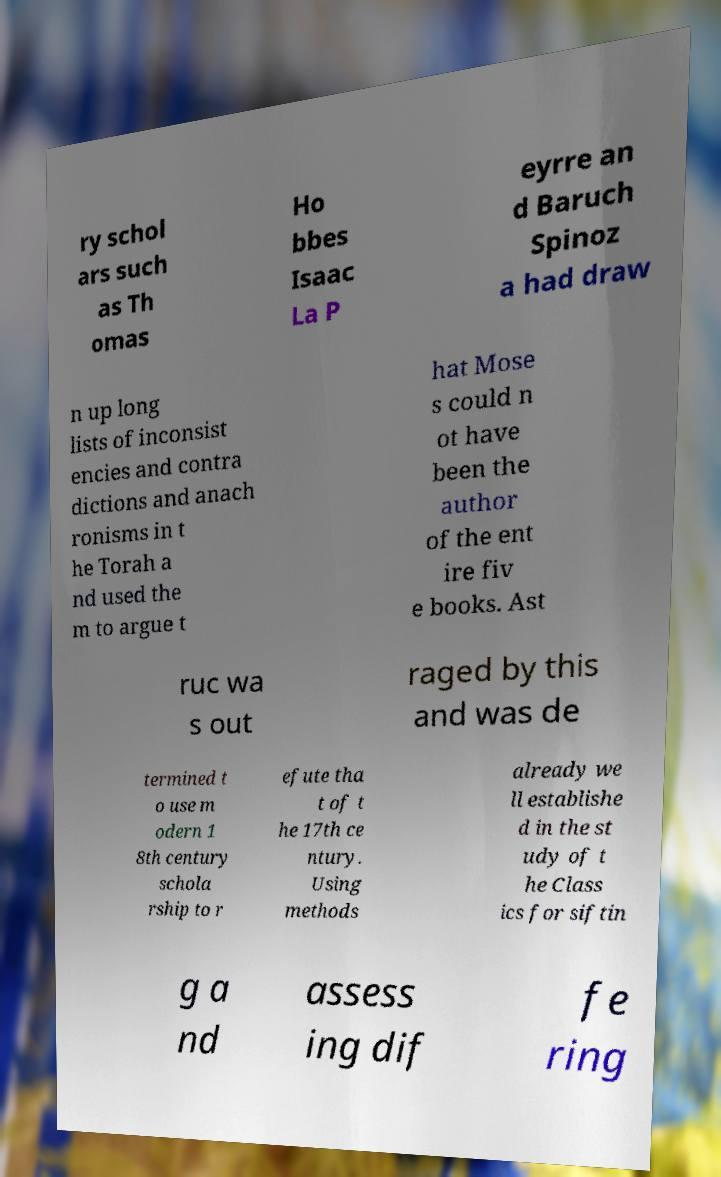Please identify and transcribe the text found in this image. ry schol ars such as Th omas Ho bbes Isaac La P eyrre an d Baruch Spinoz a had draw n up long lists of inconsist encies and contra dictions and anach ronisms in t he Torah a nd used the m to argue t hat Mose s could n ot have been the author of the ent ire fiv e books. Ast ruc wa s out raged by this and was de termined t o use m odern 1 8th century schola rship to r efute tha t of t he 17th ce ntury. Using methods already we ll establishe d in the st udy of t he Class ics for siftin g a nd assess ing dif fe ring 